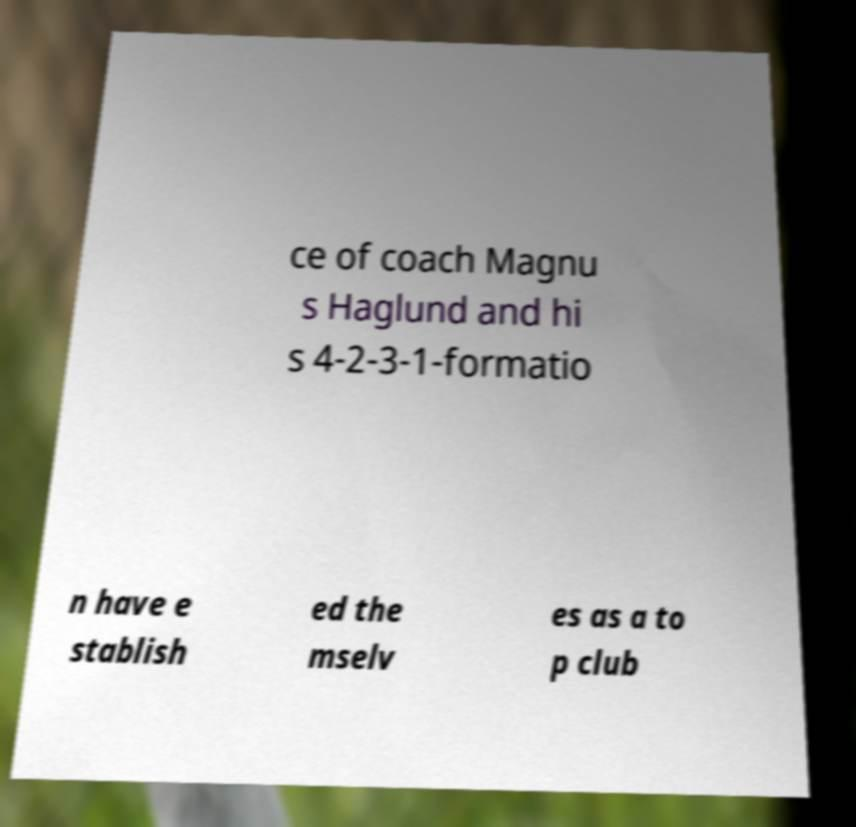Can you read and provide the text displayed in the image?This photo seems to have some interesting text. Can you extract and type it out for me? ce of coach Magnu s Haglund and hi s 4-2-3-1-formatio n have e stablish ed the mselv es as a to p club 